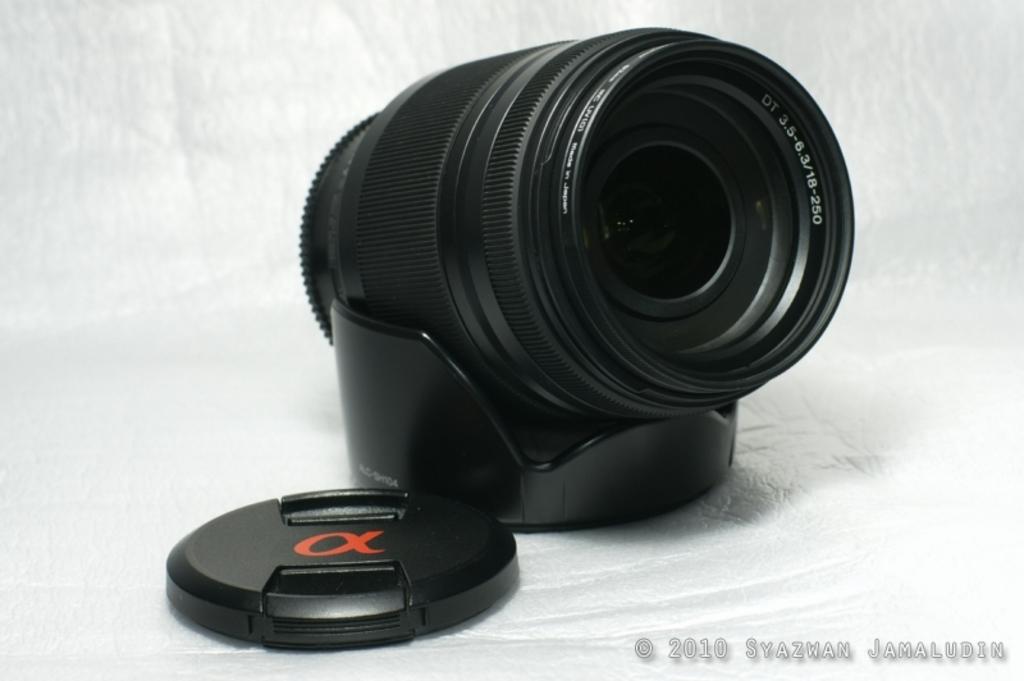What brand is this?
Provide a succinct answer. Unanswerable. 